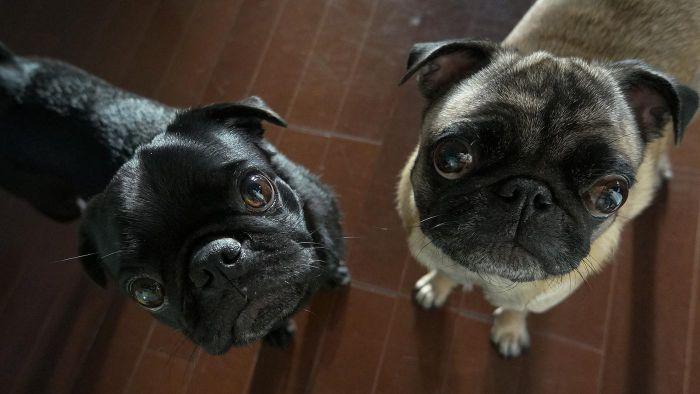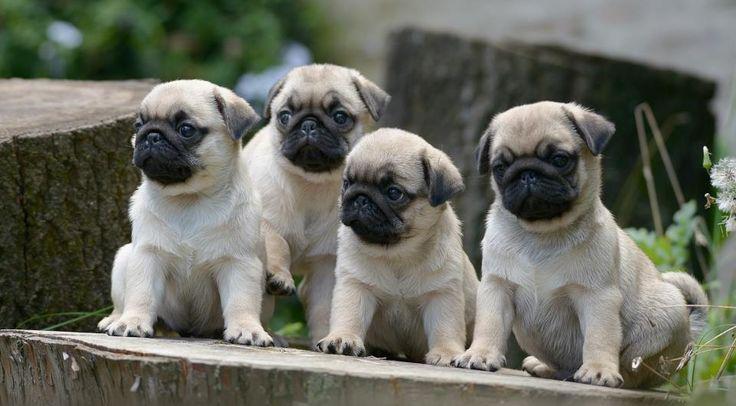The first image is the image on the left, the second image is the image on the right. Analyze the images presented: Is the assertion "One of the paired images shows exactly four pug puppies." valid? Answer yes or no. Yes. 